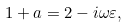<formula> <loc_0><loc_0><loc_500><loc_500>1 + a = 2 - i \omega \varepsilon ,</formula> 